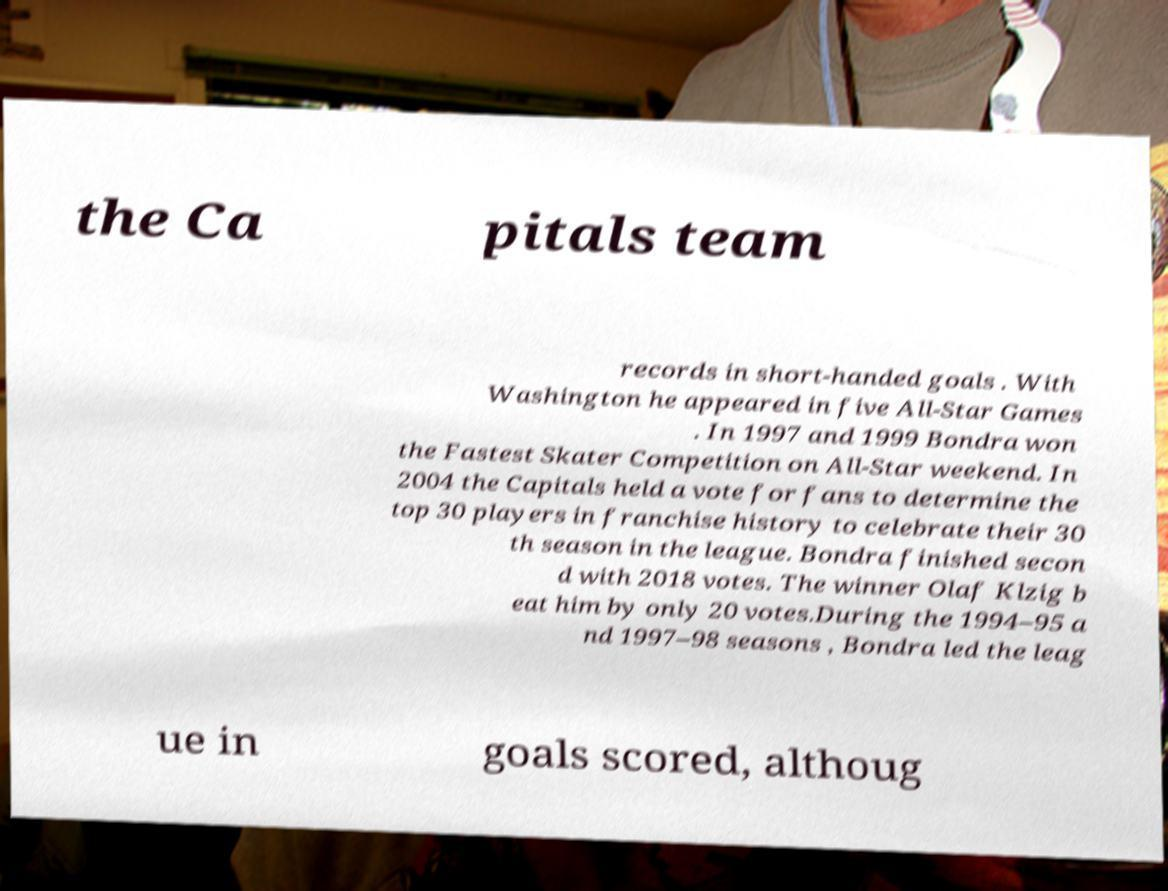Could you extract and type out the text from this image? the Ca pitals team records in short-handed goals . With Washington he appeared in five All-Star Games . In 1997 and 1999 Bondra won the Fastest Skater Competition on All-Star weekend. In 2004 the Capitals held a vote for fans to determine the top 30 players in franchise history to celebrate their 30 th season in the league. Bondra finished secon d with 2018 votes. The winner Olaf Klzig b eat him by only 20 votes.During the 1994–95 a nd 1997–98 seasons , Bondra led the leag ue in goals scored, althoug 